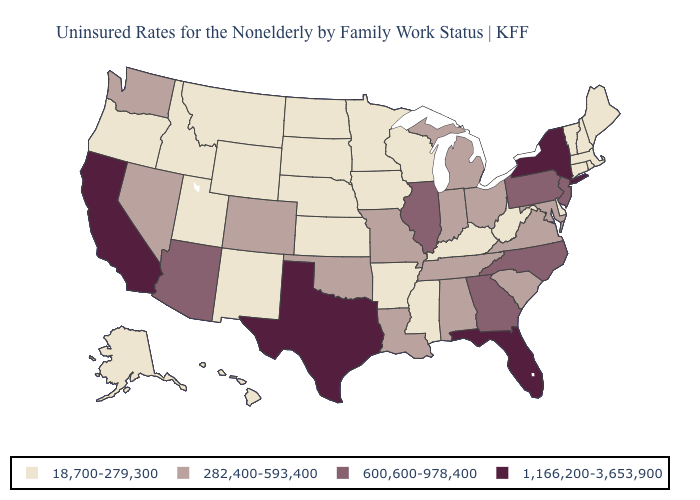What is the highest value in the Northeast ?
Concise answer only. 1,166,200-3,653,900. Which states hav the highest value in the West?
Write a very short answer. California. Name the states that have a value in the range 282,400-593,400?
Answer briefly. Alabama, Colorado, Indiana, Louisiana, Maryland, Michigan, Missouri, Nevada, Ohio, Oklahoma, South Carolina, Tennessee, Virginia, Washington. Among the states that border Wisconsin , which have the highest value?
Quick response, please. Illinois. Name the states that have a value in the range 282,400-593,400?
Give a very brief answer. Alabama, Colorado, Indiana, Louisiana, Maryland, Michigan, Missouri, Nevada, Ohio, Oklahoma, South Carolina, Tennessee, Virginia, Washington. Name the states that have a value in the range 1,166,200-3,653,900?
Keep it brief. California, Florida, New York, Texas. Which states have the lowest value in the USA?
Concise answer only. Alaska, Arkansas, Connecticut, Delaware, Hawaii, Idaho, Iowa, Kansas, Kentucky, Maine, Massachusetts, Minnesota, Mississippi, Montana, Nebraska, New Hampshire, New Mexico, North Dakota, Oregon, Rhode Island, South Dakota, Utah, Vermont, West Virginia, Wisconsin, Wyoming. What is the lowest value in the West?
Quick response, please. 18,700-279,300. What is the value of Louisiana?
Be succinct. 282,400-593,400. What is the highest value in the USA?
Short answer required. 1,166,200-3,653,900. Name the states that have a value in the range 282,400-593,400?
Concise answer only. Alabama, Colorado, Indiana, Louisiana, Maryland, Michigan, Missouri, Nevada, Ohio, Oklahoma, South Carolina, Tennessee, Virginia, Washington. Does Alaska have a lower value than West Virginia?
Concise answer only. No. What is the highest value in the West ?
Keep it brief. 1,166,200-3,653,900. Among the states that border Tennessee , which have the highest value?
Be succinct. Georgia, North Carolina. Name the states that have a value in the range 282,400-593,400?
Answer briefly. Alabama, Colorado, Indiana, Louisiana, Maryland, Michigan, Missouri, Nevada, Ohio, Oklahoma, South Carolina, Tennessee, Virginia, Washington. 